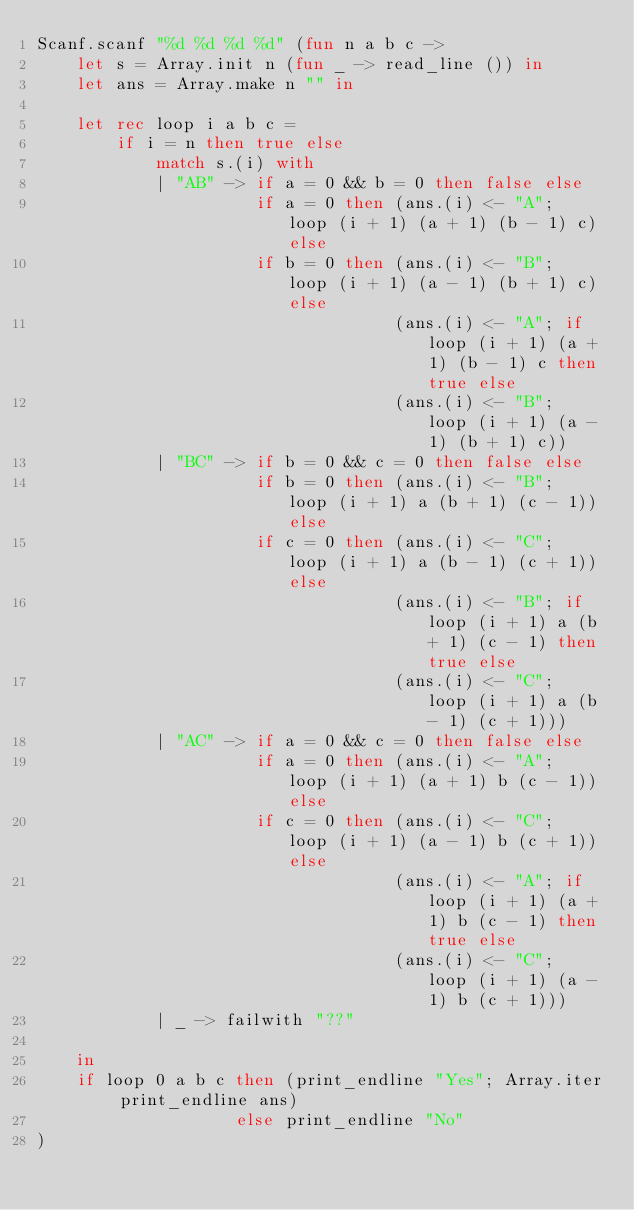Convert code to text. <code><loc_0><loc_0><loc_500><loc_500><_OCaml_>Scanf.scanf "%d %d %d %d" (fun n a b c ->
    let s = Array.init n (fun _ -> read_line ()) in 
    let ans = Array.make n "" in

    let rec loop i a b c =
        if i = n then true else
            match s.(i) with
            | "AB" -> if a = 0 && b = 0 then false else
                      if a = 0 then (ans.(i) <- "A";    loop (i + 1) (a + 1) (b - 1) c) else
                      if b = 0 then (ans.(i) <- "B";    loop (i + 1) (a - 1) (b + 1) c) else
                                    (ans.(i) <- "A"; if loop (i + 1) (a + 1) (b - 1) c then true else 
                                    (ans.(i) <- "B";    loop (i + 1) (a - 1) (b + 1) c))
            | "BC" -> if b = 0 && c = 0 then false else
                      if b = 0 then (ans.(i) <- "B";    loop (i + 1) a (b + 1) (c - 1)) else
                      if c = 0 then (ans.(i) <- "C";    loop (i + 1) a (b - 1) (c + 1)) else
                                    (ans.(i) <- "B"; if loop (i + 1) a (b + 1) (c - 1) then true else 
                                    (ans.(i) <- "C";    loop (i + 1) a (b - 1) (c + 1)))
            | "AC" -> if a = 0 && c = 0 then false else
                      if a = 0 then (ans.(i) <- "A";    loop (i + 1) (a + 1) b (c - 1)) else
                      if c = 0 then (ans.(i) <- "C";    loop (i + 1) (a - 1) b (c + 1)) else
                                    (ans.(i) <- "A"; if loop (i + 1) (a + 1) b (c - 1) then true else 
                                    (ans.(i) <- "C";    loop (i + 1) (a - 1) b (c + 1)))
            | _ -> failwith "??"

    in
    if loop 0 a b c then (print_endline "Yes"; Array.iter print_endline ans)
                    else print_endline "No"
)</code> 